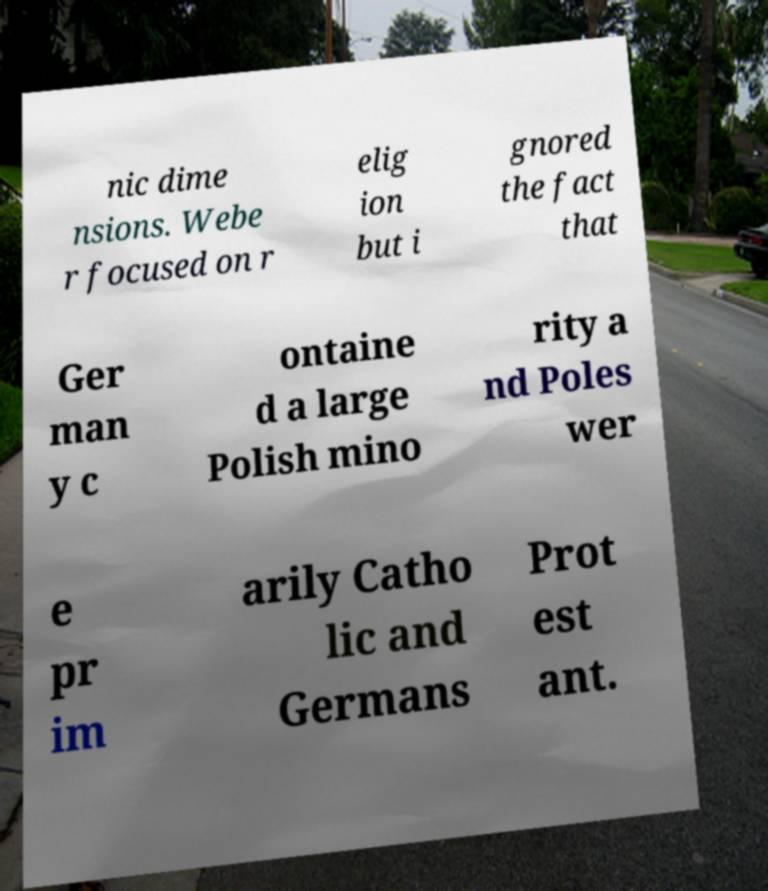Please identify and transcribe the text found in this image. nic dime nsions. Webe r focused on r elig ion but i gnored the fact that Ger man y c ontaine d a large Polish mino rity a nd Poles wer e pr im arily Catho lic and Germans Prot est ant. 